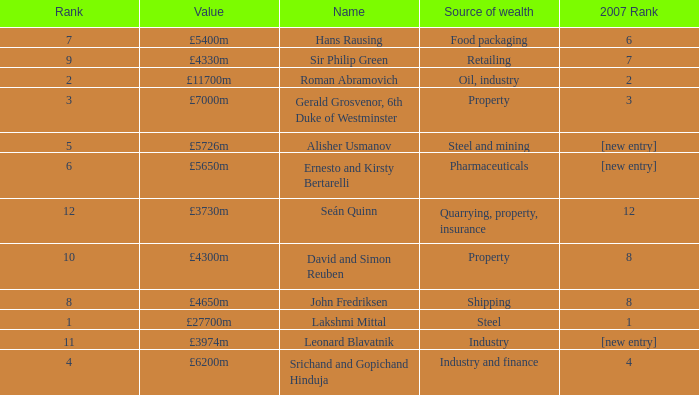What source of wealth has a value of £5726m? Steel and mining. 